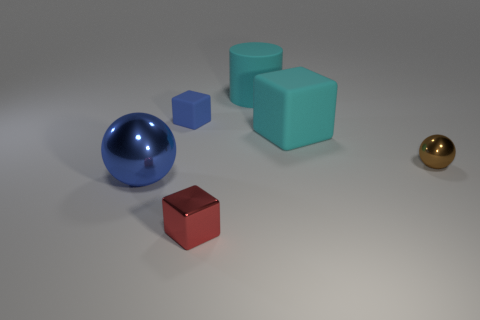There is a small thing that is the same shape as the big blue metal object; what color is it?
Provide a succinct answer. Brown. Are there more big cyan blocks behind the tiny brown shiny ball than big matte objects that are in front of the blue cube?
Give a very brief answer. No. How many other things are there of the same shape as the tiny blue matte object?
Your answer should be very brief. 2. Are there any tiny brown objects to the right of the large cyan matte thing that is behind the tiny rubber thing?
Your response must be concise. Yes. What number of cyan rubber blocks are there?
Your response must be concise. 1. Is the color of the large block the same as the big thing behind the tiny blue matte block?
Make the answer very short. Yes. Are there more large matte cylinders than tiny purple rubber objects?
Your answer should be compact. Yes. Are there any other things of the same color as the big rubber cylinder?
Your answer should be compact. Yes. What number of other objects are the same size as the red block?
Ensure brevity in your answer.  2. The thing that is in front of the metal sphere in front of the sphere that is right of the large cyan cube is made of what material?
Keep it short and to the point. Metal. 